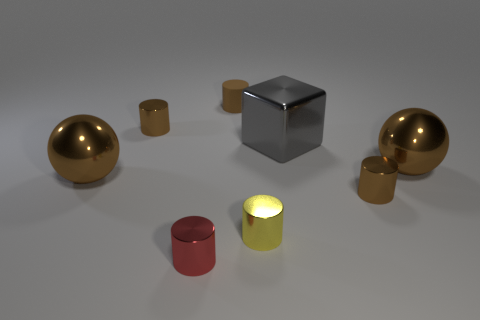Can you describe the textural differences between the objects? The objects have smooth surfaces with high reflectivity, indicating a polished texture across the board. There don't appear to be any significant textural differences that can be discerned from the image; the uniformity in texture helps to unify the different geometric shapes present. 